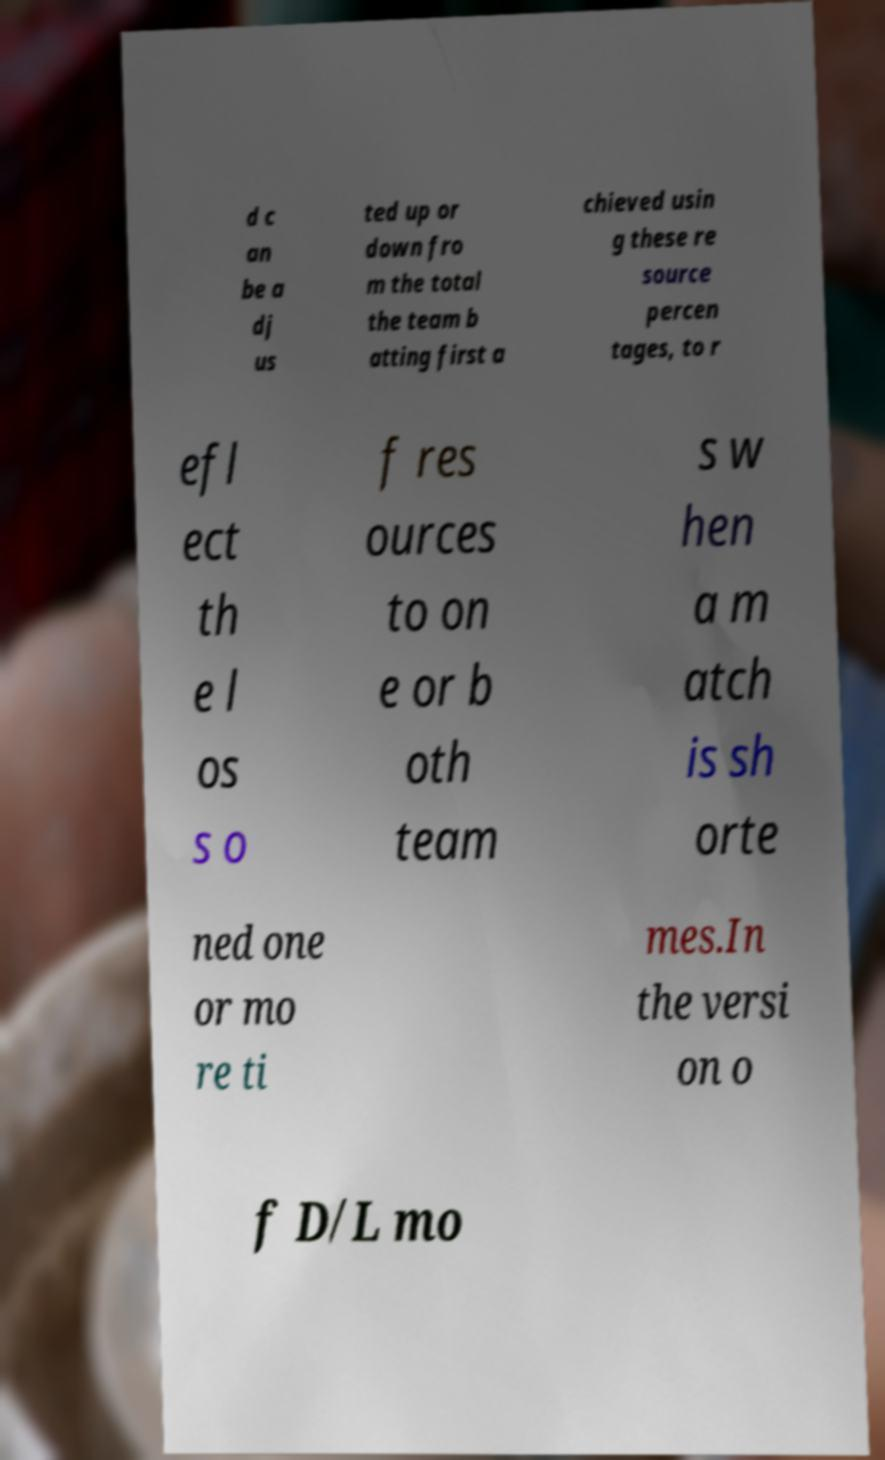Please read and relay the text visible in this image. What does it say? d c an be a dj us ted up or down fro m the total the team b atting first a chieved usin g these re source percen tages, to r efl ect th e l os s o f res ources to on e or b oth team s w hen a m atch is sh orte ned one or mo re ti mes.In the versi on o f D/L mo 